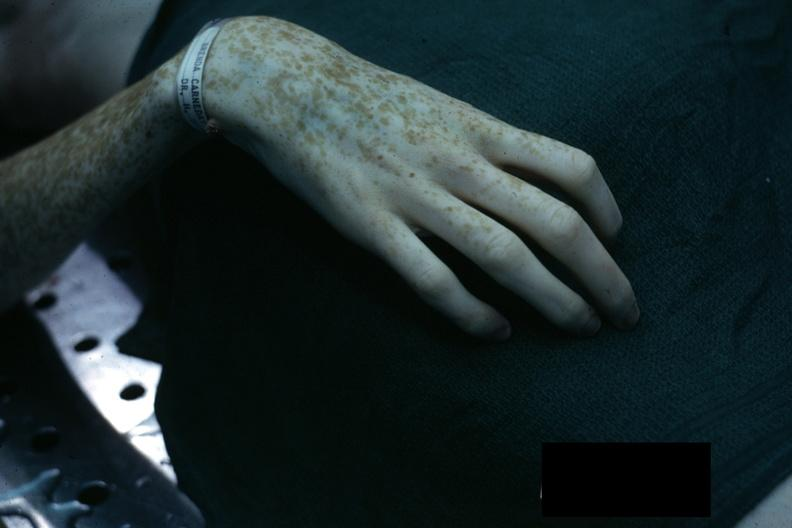what are present?
Answer the question using a single word or phrase. Extremities 